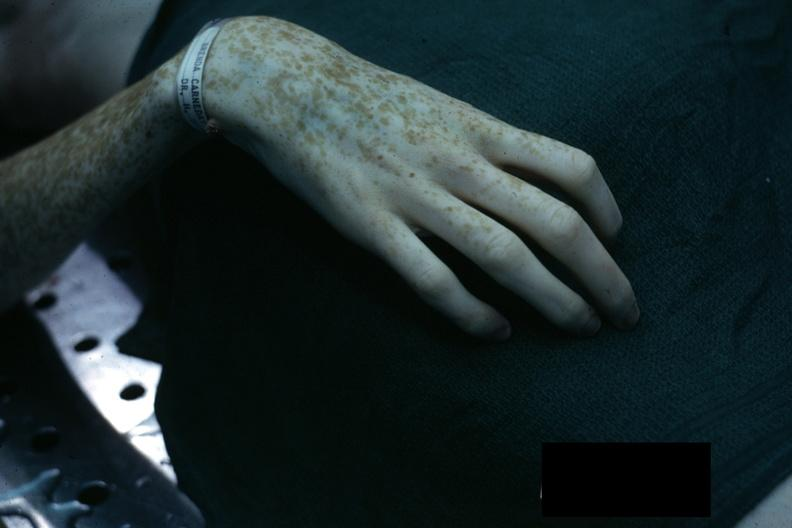what are present?
Answer the question using a single word or phrase. Extremities 